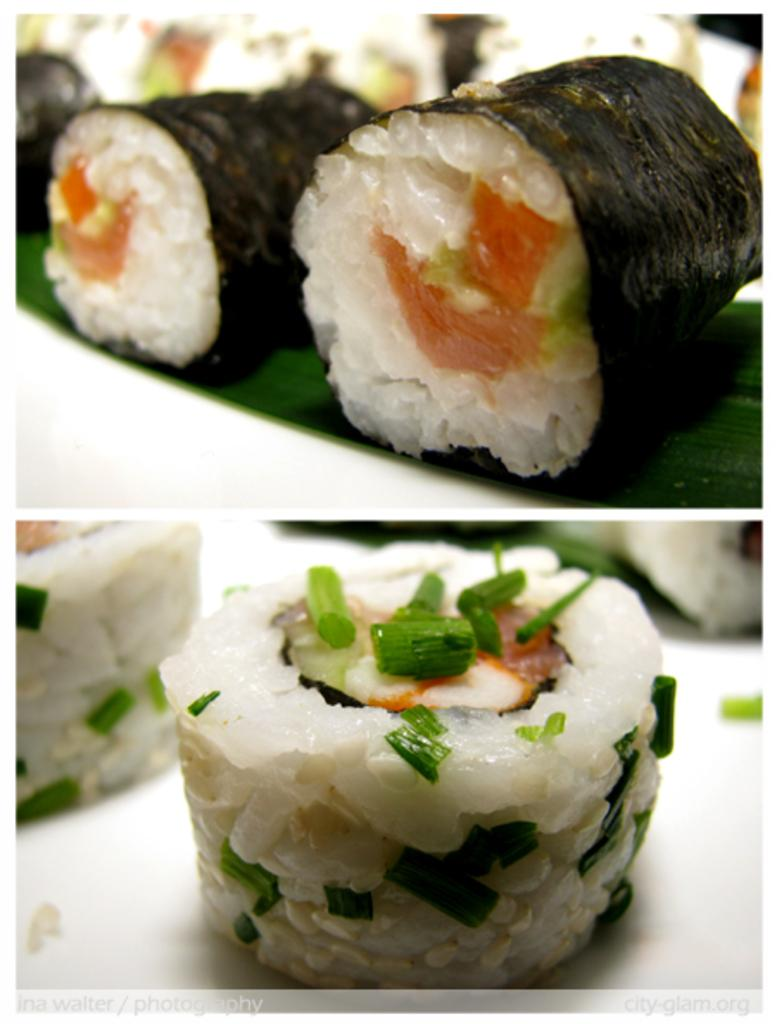What type of artwork is depicted in the image? The image is a collage. What can be found within the collage? Food is present in the collage. How many cacti are visible in the image? There are no cacti present in the image; it is a collage featuring food. What type of oil is being used in the image? There is no oil present in the image, as it is a collage featuring food. 